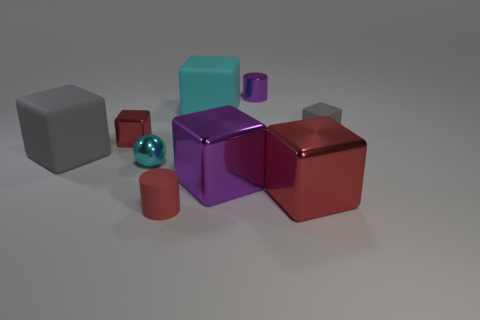Do the objects give any indication of the light source direction? Yes, the shadows and highlights on the objects suggest that the light source is coming from the upper left side of the image. 